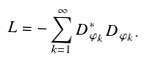Convert formula to latex. <formula><loc_0><loc_0><loc_500><loc_500>L = - \sum _ { k = 1 } ^ { \infty } D ^ { * } _ { \varphi _ { k } } D _ { \varphi _ { k } } .</formula> 